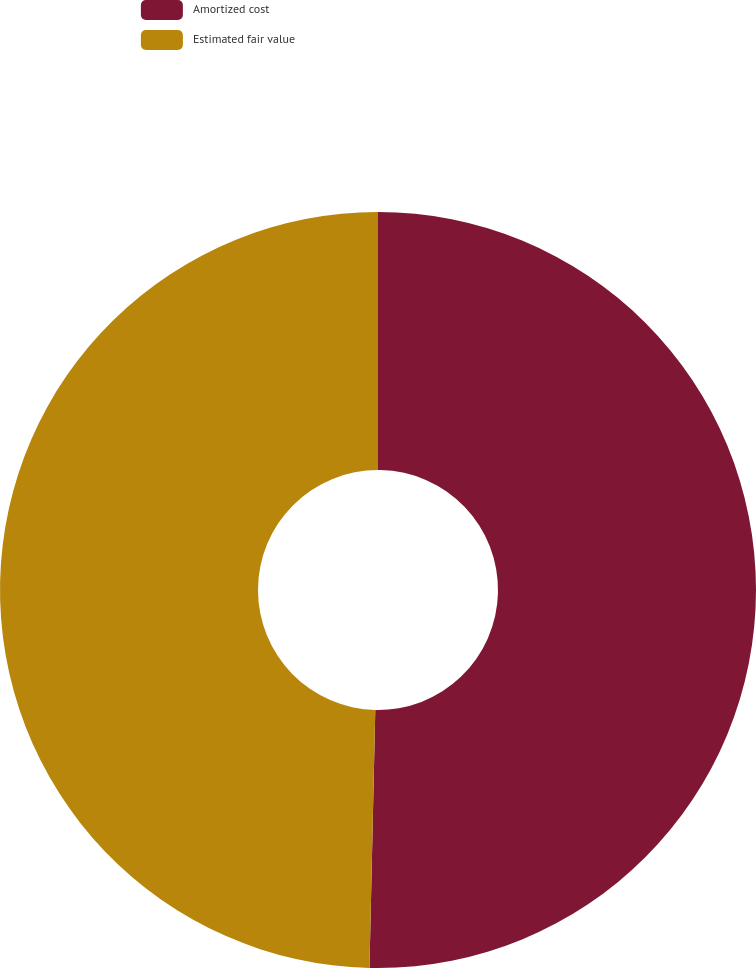Convert chart. <chart><loc_0><loc_0><loc_500><loc_500><pie_chart><fcel>Amortized cost<fcel>Estimated fair value<nl><fcel>50.36%<fcel>49.64%<nl></chart> 